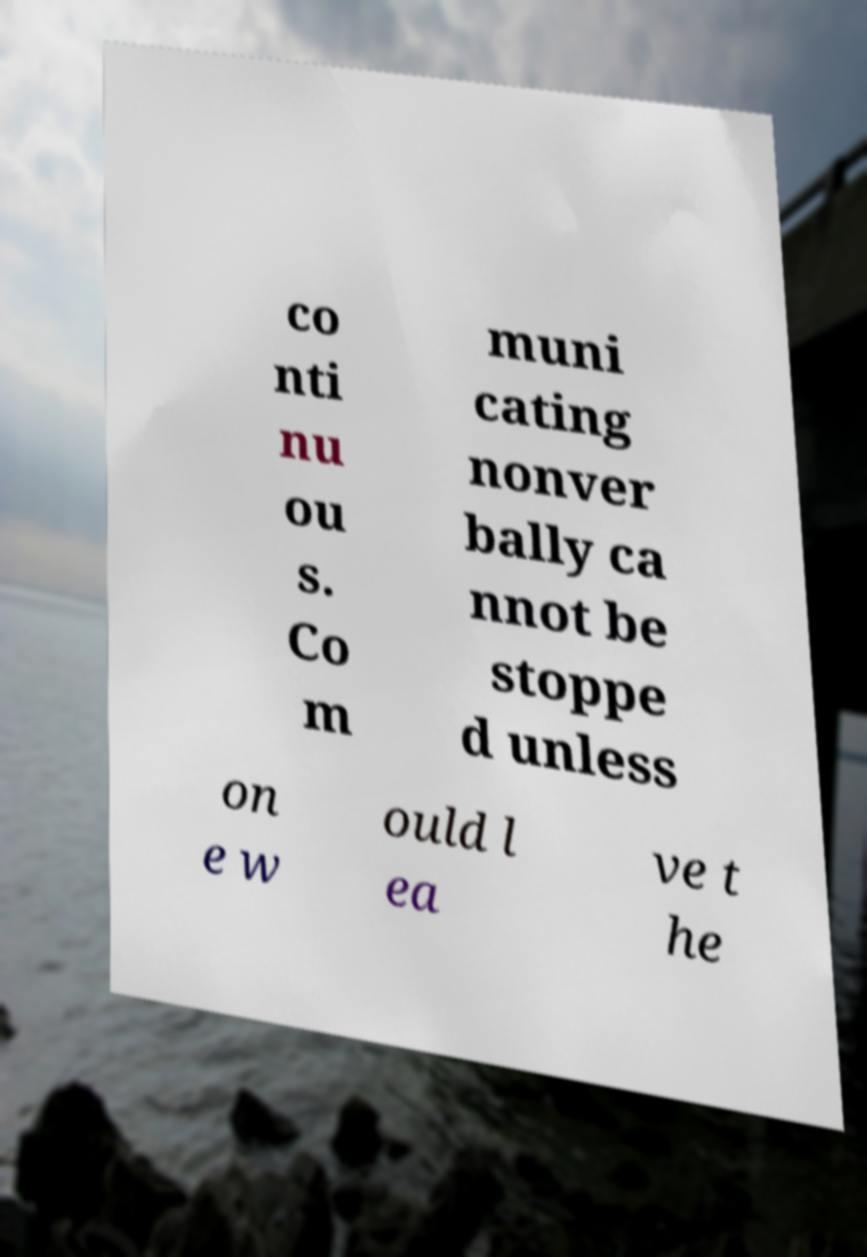What messages or text are displayed in this image? I need them in a readable, typed format. co nti nu ou s. Co m muni cating nonver bally ca nnot be stoppe d unless on e w ould l ea ve t he 